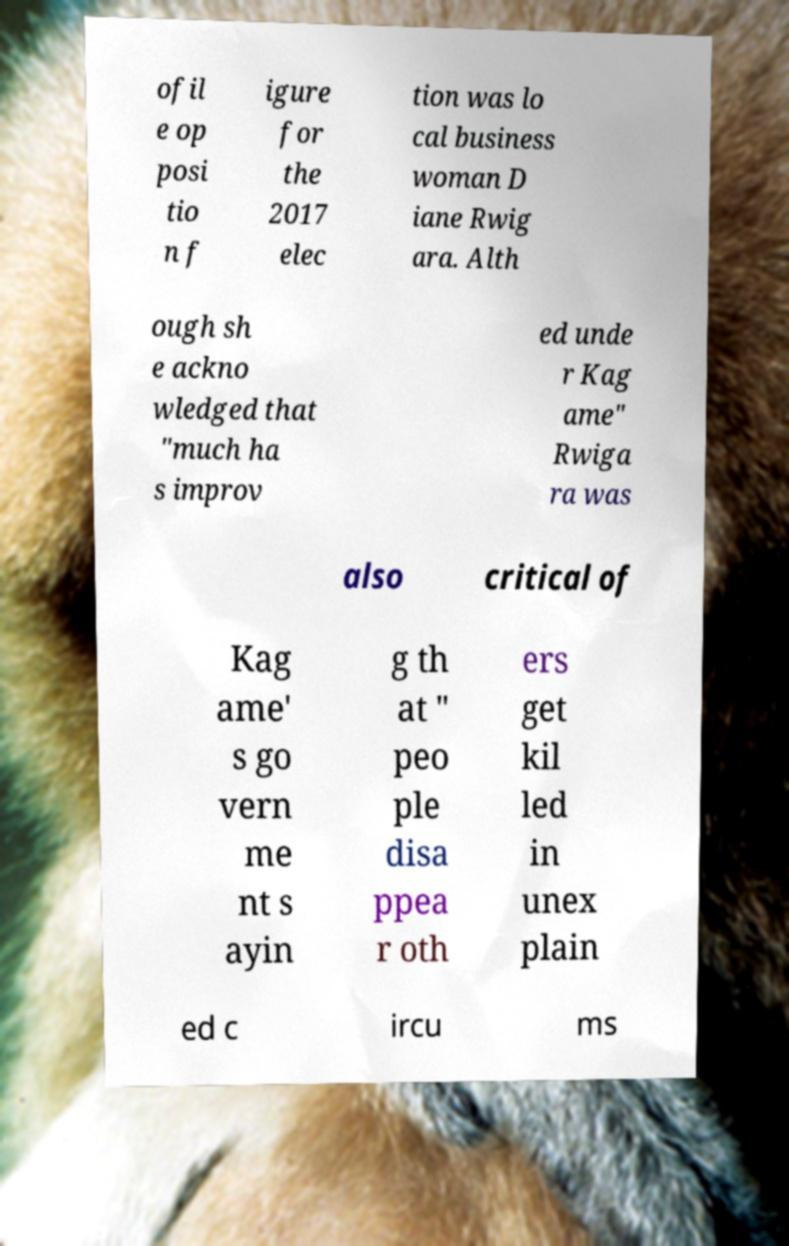Please read and relay the text visible in this image. What does it say? ofil e op posi tio n f igure for the 2017 elec tion was lo cal business woman D iane Rwig ara. Alth ough sh e ackno wledged that "much ha s improv ed unde r Kag ame" Rwiga ra was also critical of Kag ame' s go vern me nt s ayin g th at " peo ple disa ppea r oth ers get kil led in unex plain ed c ircu ms 